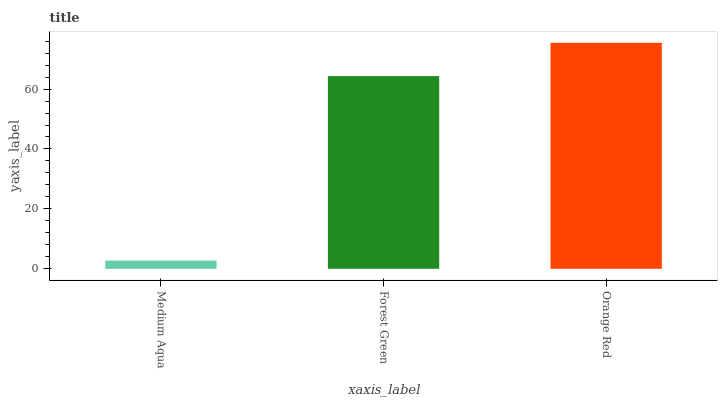Is Medium Aqua the minimum?
Answer yes or no. Yes. Is Orange Red the maximum?
Answer yes or no. Yes. Is Forest Green the minimum?
Answer yes or no. No. Is Forest Green the maximum?
Answer yes or no. No. Is Forest Green greater than Medium Aqua?
Answer yes or no. Yes. Is Medium Aqua less than Forest Green?
Answer yes or no. Yes. Is Medium Aqua greater than Forest Green?
Answer yes or no. No. Is Forest Green less than Medium Aqua?
Answer yes or no. No. Is Forest Green the high median?
Answer yes or no. Yes. Is Forest Green the low median?
Answer yes or no. Yes. Is Orange Red the high median?
Answer yes or no. No. Is Medium Aqua the low median?
Answer yes or no. No. 